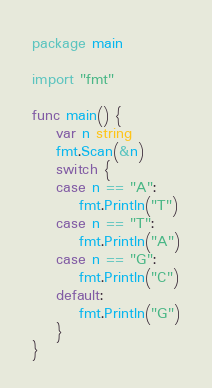Convert code to text. <code><loc_0><loc_0><loc_500><loc_500><_Go_>package main

import "fmt"

func main() {
	var n string
	fmt.Scan(&n)
	switch {
	case n == "A":
		fmt.Println("T")
	case n == "T":
		fmt.Println("A")
	case n == "G":
		fmt.Println("C")
	default:
		fmt.Println("G")
	}
}
</code> 